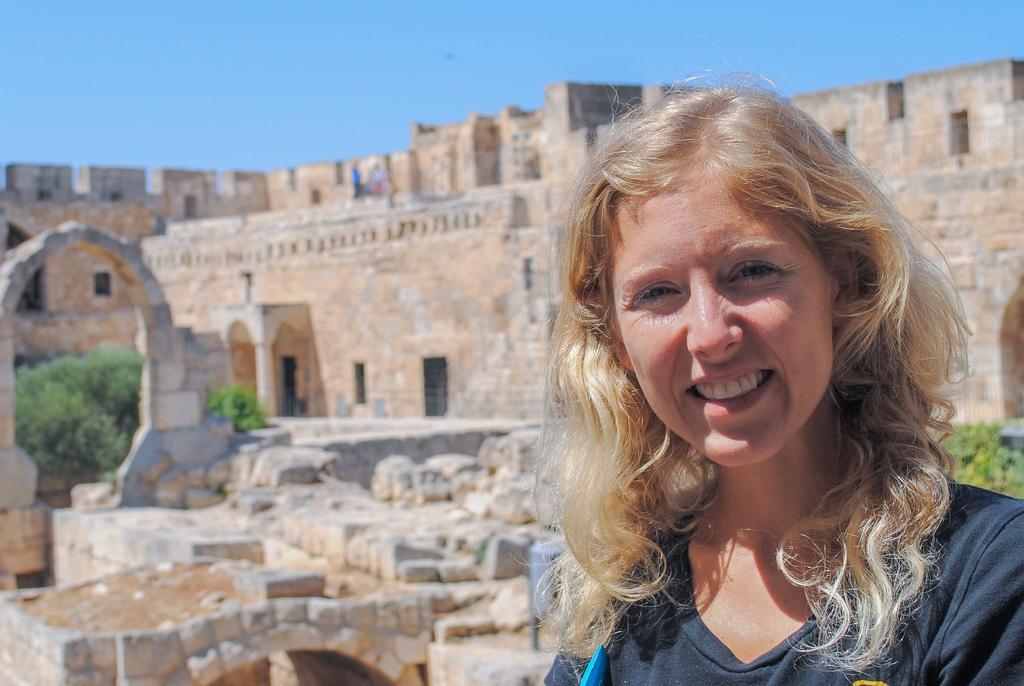Please provide a concise description of this image. In the picture we can see a woman standing and smiling and she is wearing a black T-shirt and with a golden hair and in the background, we can see a historical construction building with some broken walls and stones near it and behind it we can see a sky. 